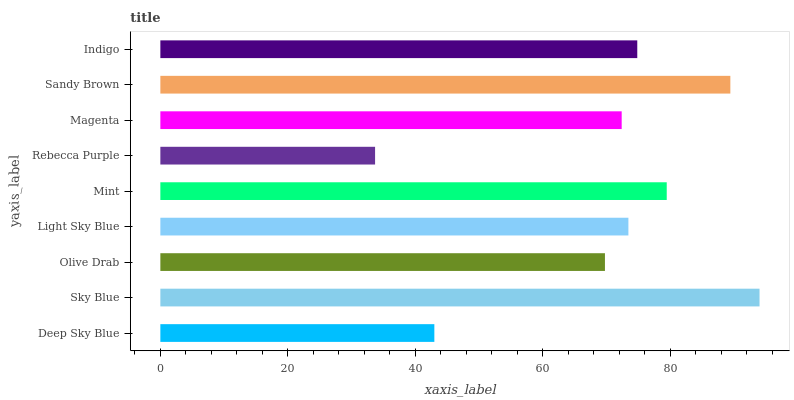Is Rebecca Purple the minimum?
Answer yes or no. Yes. Is Sky Blue the maximum?
Answer yes or no. Yes. Is Olive Drab the minimum?
Answer yes or no. No. Is Olive Drab the maximum?
Answer yes or no. No. Is Sky Blue greater than Olive Drab?
Answer yes or no. Yes. Is Olive Drab less than Sky Blue?
Answer yes or no. Yes. Is Olive Drab greater than Sky Blue?
Answer yes or no. No. Is Sky Blue less than Olive Drab?
Answer yes or no. No. Is Light Sky Blue the high median?
Answer yes or no. Yes. Is Light Sky Blue the low median?
Answer yes or no. Yes. Is Magenta the high median?
Answer yes or no. No. Is Magenta the low median?
Answer yes or no. No. 